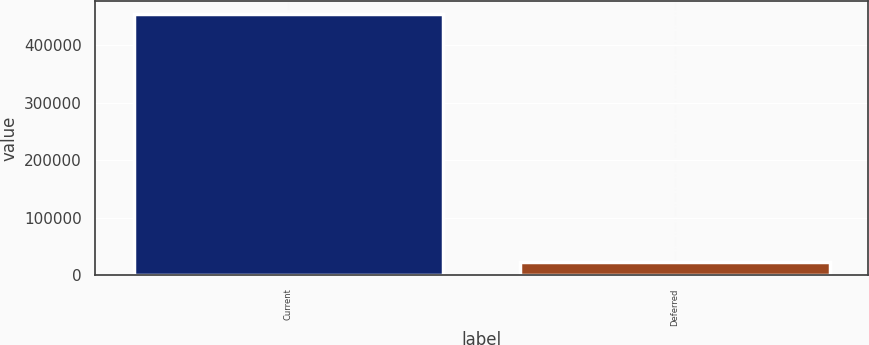<chart> <loc_0><loc_0><loc_500><loc_500><bar_chart><fcel>Current<fcel>Deferred<nl><fcel>453821<fcel>23876<nl></chart> 